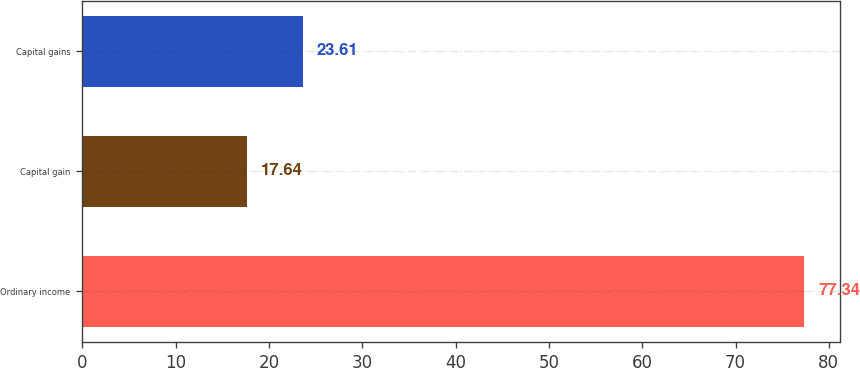Convert chart to OTSL. <chart><loc_0><loc_0><loc_500><loc_500><bar_chart><fcel>Ordinary income<fcel>Capital gain<fcel>Capital gains<nl><fcel>77.34<fcel>17.64<fcel>23.61<nl></chart> 